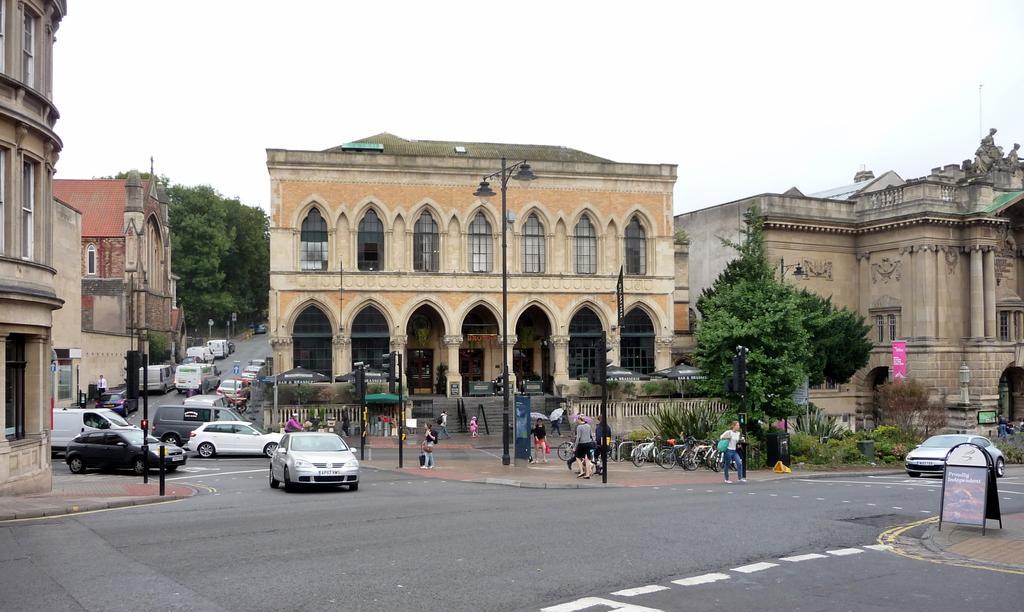Describe this image in one or two sentences. In this picture we can see few poles, buildings, vehicles and group of people, in the background we can see few trees, tents, hoardings and bicycles. 